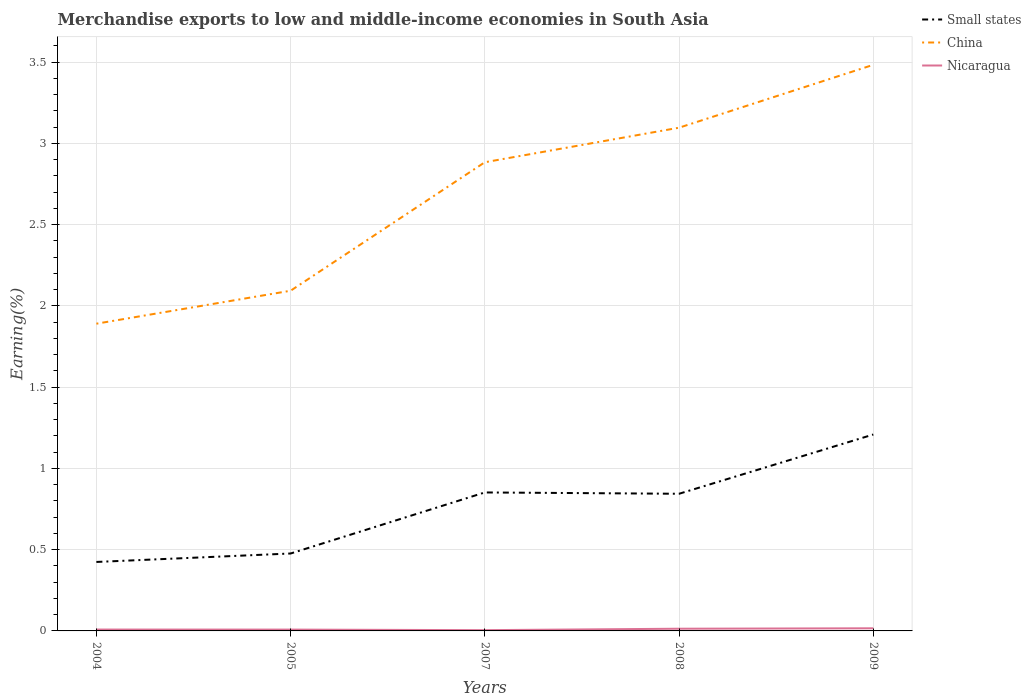Is the number of lines equal to the number of legend labels?
Offer a very short reply. Yes. Across all years, what is the maximum percentage of amount earned from merchandise exports in Nicaragua?
Provide a short and direct response. 0. In which year was the percentage of amount earned from merchandise exports in Nicaragua maximum?
Your response must be concise. 2007. What is the total percentage of amount earned from merchandise exports in Nicaragua in the graph?
Offer a terse response. -0. What is the difference between the highest and the second highest percentage of amount earned from merchandise exports in Small states?
Offer a very short reply. 0.78. What is the difference between the highest and the lowest percentage of amount earned from merchandise exports in Small states?
Provide a succinct answer. 3. Is the percentage of amount earned from merchandise exports in Small states strictly greater than the percentage of amount earned from merchandise exports in Nicaragua over the years?
Your answer should be compact. No. How many years are there in the graph?
Your answer should be very brief. 5. What is the difference between two consecutive major ticks on the Y-axis?
Your answer should be very brief. 0.5. Are the values on the major ticks of Y-axis written in scientific E-notation?
Your answer should be compact. No. How are the legend labels stacked?
Make the answer very short. Vertical. What is the title of the graph?
Make the answer very short. Merchandise exports to low and middle-income economies in South Asia. Does "Chile" appear as one of the legend labels in the graph?
Ensure brevity in your answer.  No. What is the label or title of the X-axis?
Ensure brevity in your answer.  Years. What is the label or title of the Y-axis?
Provide a short and direct response. Earning(%). What is the Earning(%) in Small states in 2004?
Provide a succinct answer. 0.42. What is the Earning(%) in China in 2004?
Make the answer very short. 1.89. What is the Earning(%) of Nicaragua in 2004?
Offer a very short reply. 0.01. What is the Earning(%) of Small states in 2005?
Provide a succinct answer. 0.48. What is the Earning(%) of China in 2005?
Keep it short and to the point. 2.09. What is the Earning(%) of Nicaragua in 2005?
Keep it short and to the point. 0.01. What is the Earning(%) in Small states in 2007?
Make the answer very short. 0.85. What is the Earning(%) of China in 2007?
Provide a succinct answer. 2.88. What is the Earning(%) in Nicaragua in 2007?
Offer a very short reply. 0. What is the Earning(%) of Small states in 2008?
Keep it short and to the point. 0.84. What is the Earning(%) of China in 2008?
Provide a succinct answer. 3.1. What is the Earning(%) of Nicaragua in 2008?
Offer a terse response. 0.01. What is the Earning(%) of Small states in 2009?
Make the answer very short. 1.21. What is the Earning(%) of China in 2009?
Ensure brevity in your answer.  3.48. What is the Earning(%) in Nicaragua in 2009?
Provide a succinct answer. 0.02. Across all years, what is the maximum Earning(%) in Small states?
Your answer should be very brief. 1.21. Across all years, what is the maximum Earning(%) of China?
Keep it short and to the point. 3.48. Across all years, what is the maximum Earning(%) in Nicaragua?
Provide a short and direct response. 0.02. Across all years, what is the minimum Earning(%) in Small states?
Provide a succinct answer. 0.42. Across all years, what is the minimum Earning(%) in China?
Offer a very short reply. 1.89. Across all years, what is the minimum Earning(%) in Nicaragua?
Provide a short and direct response. 0. What is the total Earning(%) in Small states in the graph?
Make the answer very short. 3.81. What is the total Earning(%) in China in the graph?
Keep it short and to the point. 13.45. What is the total Earning(%) in Nicaragua in the graph?
Make the answer very short. 0.05. What is the difference between the Earning(%) of Small states in 2004 and that in 2005?
Your answer should be very brief. -0.05. What is the difference between the Earning(%) of China in 2004 and that in 2005?
Offer a terse response. -0.2. What is the difference between the Earning(%) in Small states in 2004 and that in 2007?
Your answer should be very brief. -0.43. What is the difference between the Earning(%) of China in 2004 and that in 2007?
Provide a succinct answer. -0.99. What is the difference between the Earning(%) in Nicaragua in 2004 and that in 2007?
Offer a terse response. 0. What is the difference between the Earning(%) in Small states in 2004 and that in 2008?
Make the answer very short. -0.42. What is the difference between the Earning(%) in China in 2004 and that in 2008?
Offer a terse response. -1.21. What is the difference between the Earning(%) in Nicaragua in 2004 and that in 2008?
Your answer should be compact. -0.01. What is the difference between the Earning(%) of Small states in 2004 and that in 2009?
Provide a short and direct response. -0.78. What is the difference between the Earning(%) of China in 2004 and that in 2009?
Offer a terse response. -1.59. What is the difference between the Earning(%) of Nicaragua in 2004 and that in 2009?
Provide a succinct answer. -0.01. What is the difference between the Earning(%) in Small states in 2005 and that in 2007?
Provide a succinct answer. -0.38. What is the difference between the Earning(%) in China in 2005 and that in 2007?
Make the answer very short. -0.79. What is the difference between the Earning(%) in Nicaragua in 2005 and that in 2007?
Keep it short and to the point. 0. What is the difference between the Earning(%) in Small states in 2005 and that in 2008?
Offer a terse response. -0.37. What is the difference between the Earning(%) in China in 2005 and that in 2008?
Ensure brevity in your answer.  -1. What is the difference between the Earning(%) in Nicaragua in 2005 and that in 2008?
Offer a terse response. -0.01. What is the difference between the Earning(%) of Small states in 2005 and that in 2009?
Give a very brief answer. -0.73. What is the difference between the Earning(%) of China in 2005 and that in 2009?
Provide a succinct answer. -1.39. What is the difference between the Earning(%) of Nicaragua in 2005 and that in 2009?
Provide a succinct answer. -0.01. What is the difference between the Earning(%) in Small states in 2007 and that in 2008?
Your response must be concise. 0.01. What is the difference between the Earning(%) of China in 2007 and that in 2008?
Offer a very short reply. -0.21. What is the difference between the Earning(%) in Nicaragua in 2007 and that in 2008?
Ensure brevity in your answer.  -0.01. What is the difference between the Earning(%) in Small states in 2007 and that in 2009?
Provide a short and direct response. -0.36. What is the difference between the Earning(%) of China in 2007 and that in 2009?
Ensure brevity in your answer.  -0.6. What is the difference between the Earning(%) of Nicaragua in 2007 and that in 2009?
Provide a succinct answer. -0.01. What is the difference between the Earning(%) in Small states in 2008 and that in 2009?
Offer a terse response. -0.36. What is the difference between the Earning(%) in China in 2008 and that in 2009?
Provide a short and direct response. -0.39. What is the difference between the Earning(%) of Nicaragua in 2008 and that in 2009?
Your response must be concise. -0. What is the difference between the Earning(%) of Small states in 2004 and the Earning(%) of China in 2005?
Offer a terse response. -1.67. What is the difference between the Earning(%) in Small states in 2004 and the Earning(%) in Nicaragua in 2005?
Your answer should be very brief. 0.42. What is the difference between the Earning(%) of China in 2004 and the Earning(%) of Nicaragua in 2005?
Your answer should be compact. 1.88. What is the difference between the Earning(%) in Small states in 2004 and the Earning(%) in China in 2007?
Provide a succinct answer. -2.46. What is the difference between the Earning(%) in Small states in 2004 and the Earning(%) in Nicaragua in 2007?
Your answer should be compact. 0.42. What is the difference between the Earning(%) in China in 2004 and the Earning(%) in Nicaragua in 2007?
Your response must be concise. 1.89. What is the difference between the Earning(%) in Small states in 2004 and the Earning(%) in China in 2008?
Your answer should be very brief. -2.67. What is the difference between the Earning(%) in Small states in 2004 and the Earning(%) in Nicaragua in 2008?
Offer a very short reply. 0.41. What is the difference between the Earning(%) of China in 2004 and the Earning(%) of Nicaragua in 2008?
Ensure brevity in your answer.  1.88. What is the difference between the Earning(%) of Small states in 2004 and the Earning(%) of China in 2009?
Keep it short and to the point. -3.06. What is the difference between the Earning(%) in Small states in 2004 and the Earning(%) in Nicaragua in 2009?
Provide a short and direct response. 0.41. What is the difference between the Earning(%) in China in 2004 and the Earning(%) in Nicaragua in 2009?
Ensure brevity in your answer.  1.87. What is the difference between the Earning(%) in Small states in 2005 and the Earning(%) in China in 2007?
Give a very brief answer. -2.41. What is the difference between the Earning(%) in Small states in 2005 and the Earning(%) in Nicaragua in 2007?
Your answer should be very brief. 0.47. What is the difference between the Earning(%) of China in 2005 and the Earning(%) of Nicaragua in 2007?
Keep it short and to the point. 2.09. What is the difference between the Earning(%) of Small states in 2005 and the Earning(%) of China in 2008?
Make the answer very short. -2.62. What is the difference between the Earning(%) in Small states in 2005 and the Earning(%) in Nicaragua in 2008?
Give a very brief answer. 0.46. What is the difference between the Earning(%) of China in 2005 and the Earning(%) of Nicaragua in 2008?
Ensure brevity in your answer.  2.08. What is the difference between the Earning(%) of Small states in 2005 and the Earning(%) of China in 2009?
Your answer should be very brief. -3.01. What is the difference between the Earning(%) in Small states in 2005 and the Earning(%) in Nicaragua in 2009?
Your response must be concise. 0.46. What is the difference between the Earning(%) in China in 2005 and the Earning(%) in Nicaragua in 2009?
Make the answer very short. 2.08. What is the difference between the Earning(%) of Small states in 2007 and the Earning(%) of China in 2008?
Provide a succinct answer. -2.24. What is the difference between the Earning(%) of Small states in 2007 and the Earning(%) of Nicaragua in 2008?
Keep it short and to the point. 0.84. What is the difference between the Earning(%) in China in 2007 and the Earning(%) in Nicaragua in 2008?
Give a very brief answer. 2.87. What is the difference between the Earning(%) in Small states in 2007 and the Earning(%) in China in 2009?
Your answer should be compact. -2.63. What is the difference between the Earning(%) in Small states in 2007 and the Earning(%) in Nicaragua in 2009?
Ensure brevity in your answer.  0.84. What is the difference between the Earning(%) of China in 2007 and the Earning(%) of Nicaragua in 2009?
Make the answer very short. 2.87. What is the difference between the Earning(%) in Small states in 2008 and the Earning(%) in China in 2009?
Your response must be concise. -2.64. What is the difference between the Earning(%) of Small states in 2008 and the Earning(%) of Nicaragua in 2009?
Provide a short and direct response. 0.83. What is the difference between the Earning(%) in China in 2008 and the Earning(%) in Nicaragua in 2009?
Ensure brevity in your answer.  3.08. What is the average Earning(%) of Small states per year?
Provide a succinct answer. 0.76. What is the average Earning(%) in China per year?
Make the answer very short. 2.69. What is the average Earning(%) of Nicaragua per year?
Provide a short and direct response. 0.01. In the year 2004, what is the difference between the Earning(%) in Small states and Earning(%) in China?
Offer a terse response. -1.47. In the year 2004, what is the difference between the Earning(%) of Small states and Earning(%) of Nicaragua?
Your answer should be very brief. 0.42. In the year 2004, what is the difference between the Earning(%) of China and Earning(%) of Nicaragua?
Your answer should be very brief. 1.88. In the year 2005, what is the difference between the Earning(%) in Small states and Earning(%) in China?
Provide a succinct answer. -1.62. In the year 2005, what is the difference between the Earning(%) in Small states and Earning(%) in Nicaragua?
Offer a terse response. 0.47. In the year 2005, what is the difference between the Earning(%) in China and Earning(%) in Nicaragua?
Make the answer very short. 2.09. In the year 2007, what is the difference between the Earning(%) of Small states and Earning(%) of China?
Make the answer very short. -2.03. In the year 2007, what is the difference between the Earning(%) of Small states and Earning(%) of Nicaragua?
Offer a very short reply. 0.85. In the year 2007, what is the difference between the Earning(%) of China and Earning(%) of Nicaragua?
Ensure brevity in your answer.  2.88. In the year 2008, what is the difference between the Earning(%) in Small states and Earning(%) in China?
Offer a terse response. -2.25. In the year 2008, what is the difference between the Earning(%) in Small states and Earning(%) in Nicaragua?
Make the answer very short. 0.83. In the year 2008, what is the difference between the Earning(%) in China and Earning(%) in Nicaragua?
Your answer should be compact. 3.08. In the year 2009, what is the difference between the Earning(%) of Small states and Earning(%) of China?
Provide a succinct answer. -2.28. In the year 2009, what is the difference between the Earning(%) in Small states and Earning(%) in Nicaragua?
Offer a very short reply. 1.19. In the year 2009, what is the difference between the Earning(%) of China and Earning(%) of Nicaragua?
Make the answer very short. 3.47. What is the ratio of the Earning(%) of Small states in 2004 to that in 2005?
Offer a terse response. 0.89. What is the ratio of the Earning(%) in China in 2004 to that in 2005?
Offer a very short reply. 0.9. What is the ratio of the Earning(%) in Nicaragua in 2004 to that in 2005?
Provide a succinct answer. 1.03. What is the ratio of the Earning(%) of Small states in 2004 to that in 2007?
Provide a short and direct response. 0.5. What is the ratio of the Earning(%) of China in 2004 to that in 2007?
Your answer should be very brief. 0.66. What is the ratio of the Earning(%) in Nicaragua in 2004 to that in 2007?
Your response must be concise. 1.8. What is the ratio of the Earning(%) of Small states in 2004 to that in 2008?
Your response must be concise. 0.5. What is the ratio of the Earning(%) of China in 2004 to that in 2008?
Make the answer very short. 0.61. What is the ratio of the Earning(%) in Nicaragua in 2004 to that in 2008?
Keep it short and to the point. 0.62. What is the ratio of the Earning(%) in Small states in 2004 to that in 2009?
Offer a very short reply. 0.35. What is the ratio of the Earning(%) of China in 2004 to that in 2009?
Offer a terse response. 0.54. What is the ratio of the Earning(%) in Nicaragua in 2004 to that in 2009?
Your answer should be compact. 0.52. What is the ratio of the Earning(%) in Small states in 2005 to that in 2007?
Provide a succinct answer. 0.56. What is the ratio of the Earning(%) in China in 2005 to that in 2007?
Keep it short and to the point. 0.73. What is the ratio of the Earning(%) in Nicaragua in 2005 to that in 2007?
Offer a terse response. 1.75. What is the ratio of the Earning(%) in Small states in 2005 to that in 2008?
Provide a succinct answer. 0.56. What is the ratio of the Earning(%) of China in 2005 to that in 2008?
Provide a succinct answer. 0.68. What is the ratio of the Earning(%) in Nicaragua in 2005 to that in 2008?
Ensure brevity in your answer.  0.6. What is the ratio of the Earning(%) in Small states in 2005 to that in 2009?
Provide a succinct answer. 0.39. What is the ratio of the Earning(%) in China in 2005 to that in 2009?
Your answer should be compact. 0.6. What is the ratio of the Earning(%) in Nicaragua in 2005 to that in 2009?
Ensure brevity in your answer.  0.5. What is the ratio of the Earning(%) in Small states in 2007 to that in 2008?
Provide a succinct answer. 1.01. What is the ratio of the Earning(%) in China in 2007 to that in 2008?
Make the answer very short. 0.93. What is the ratio of the Earning(%) of Nicaragua in 2007 to that in 2008?
Offer a very short reply. 0.35. What is the ratio of the Earning(%) of Small states in 2007 to that in 2009?
Offer a very short reply. 0.71. What is the ratio of the Earning(%) of China in 2007 to that in 2009?
Offer a very short reply. 0.83. What is the ratio of the Earning(%) in Nicaragua in 2007 to that in 2009?
Provide a succinct answer. 0.29. What is the ratio of the Earning(%) in Small states in 2008 to that in 2009?
Offer a terse response. 0.7. What is the ratio of the Earning(%) in China in 2008 to that in 2009?
Provide a succinct answer. 0.89. What is the ratio of the Earning(%) in Nicaragua in 2008 to that in 2009?
Your response must be concise. 0.84. What is the difference between the highest and the second highest Earning(%) of Small states?
Your answer should be very brief. 0.36. What is the difference between the highest and the second highest Earning(%) of China?
Your response must be concise. 0.39. What is the difference between the highest and the second highest Earning(%) of Nicaragua?
Give a very brief answer. 0. What is the difference between the highest and the lowest Earning(%) of Small states?
Your response must be concise. 0.78. What is the difference between the highest and the lowest Earning(%) in China?
Your response must be concise. 1.59. What is the difference between the highest and the lowest Earning(%) in Nicaragua?
Your response must be concise. 0.01. 